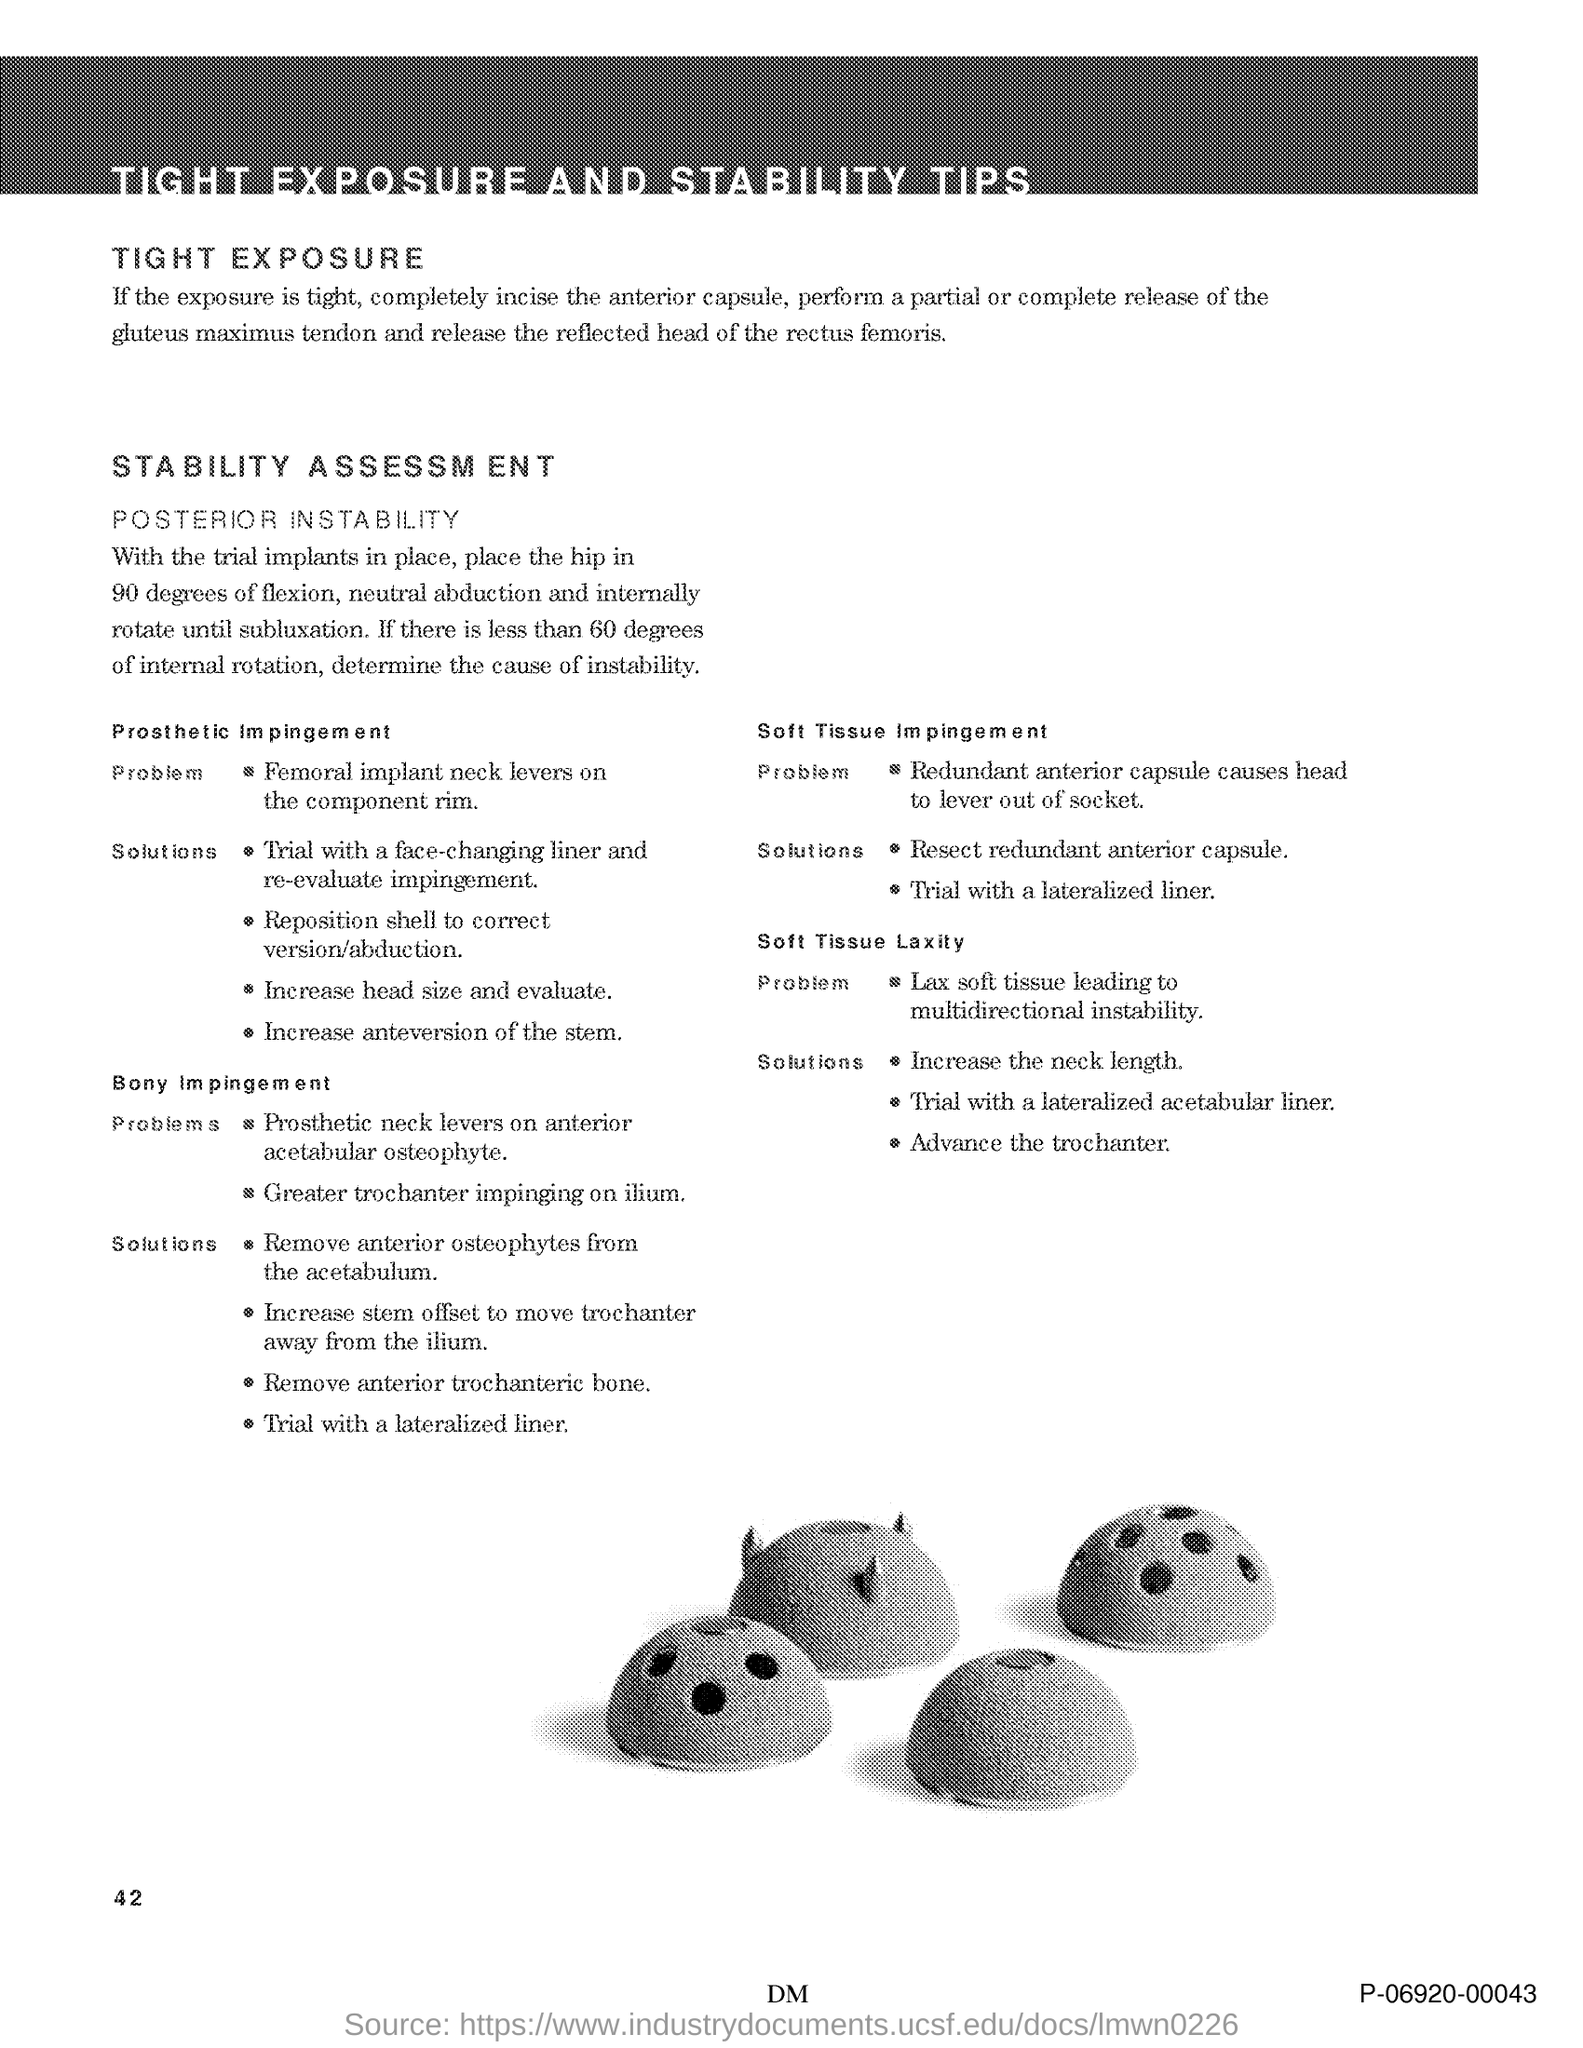Mention a couple of crucial points in this snapshot. The title of the document is 'Tight Exposure and Stability Tips.' The page number is 42. 